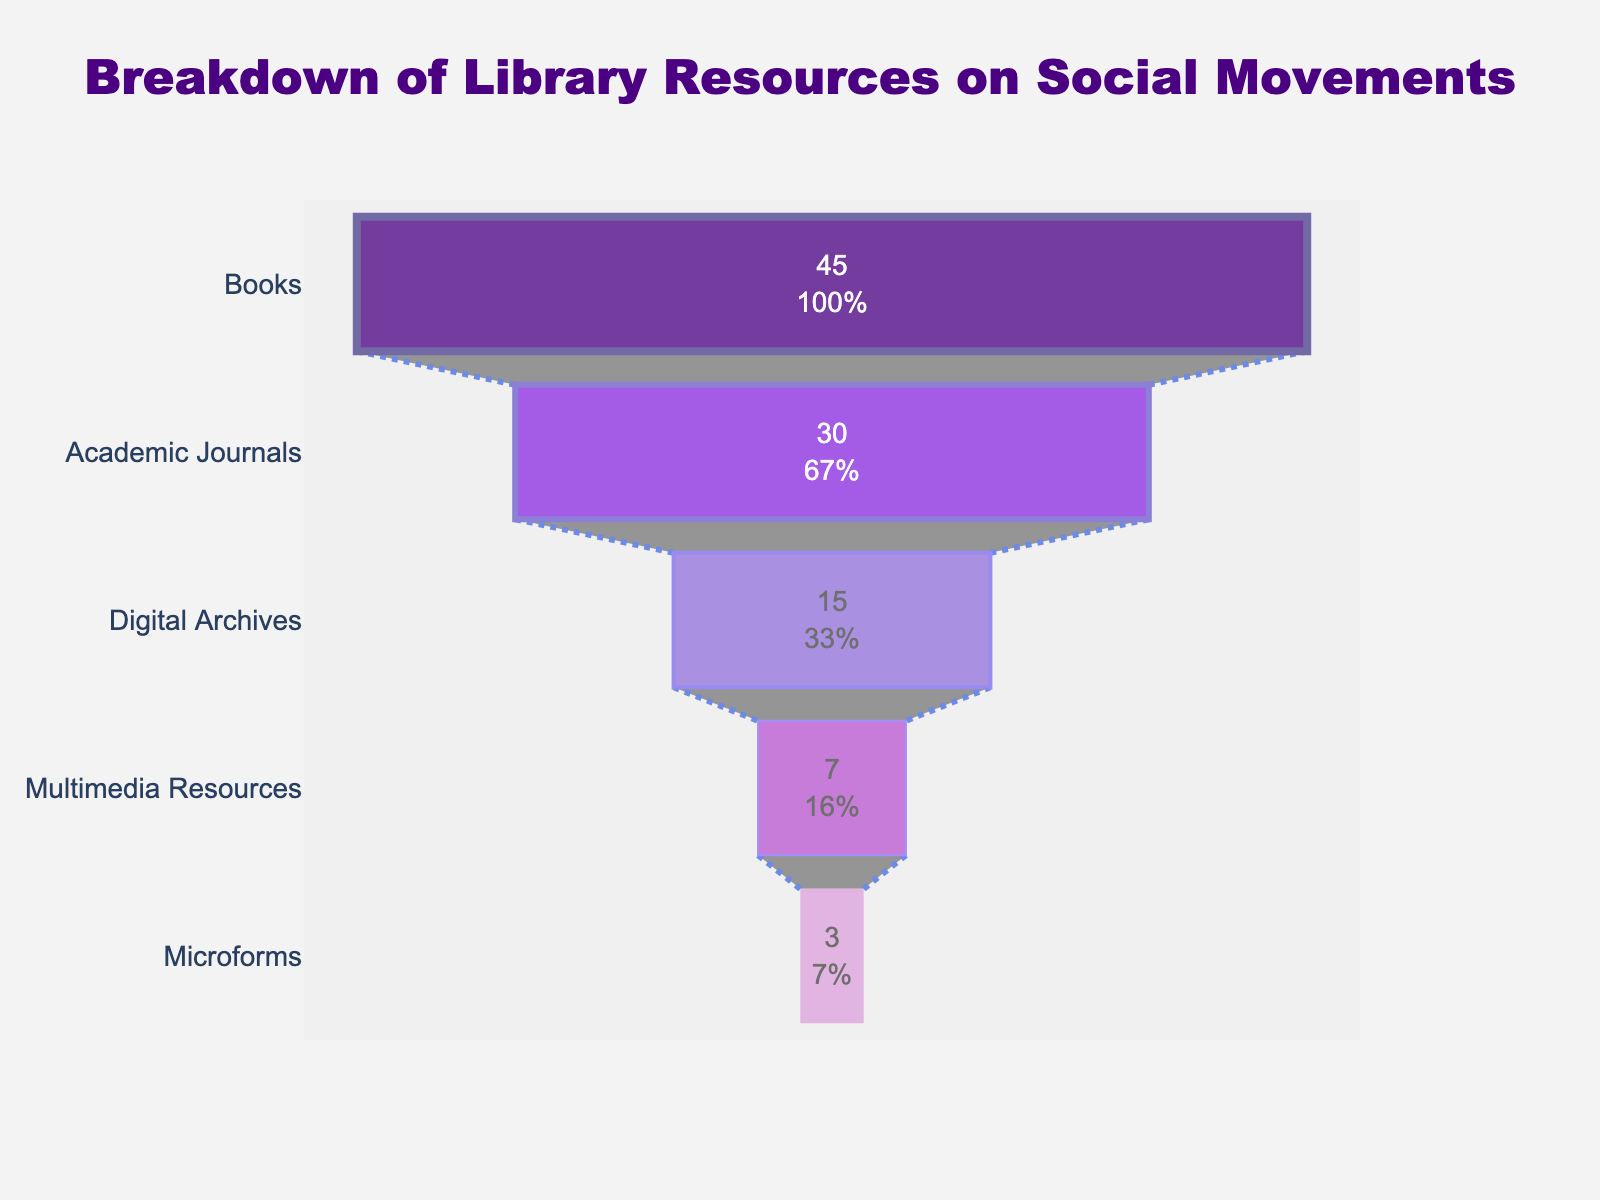What's the largest category of library resources on social movements? The title of the chart is "Breakdown of Library Resources on Social Movements", and the largest segment highlighted in the chart represents the highest percentage. The books segment is at the top, which means it's the largest category.
Answer: Books What percentage of resources are digital archives? Look for the segment labeled "Digital Archives" and directly read the percentage associated with it.
Answer: 15% How many types of library resources on social movements are represented in the chart? Count the unique segments of the chart representing different mediums. The segments are Books, Academic Journals, Digital Archives, Multimedia Resources, and Microforms.
Answer: 5 Which category represents the second highest percentage of resources? The second segment from the top of the funnel chart represents the second highest category, which is "Academic Journals" at 30%.
Answer: Academic Journals What's the combined percentage of multimedia resources and microforms? Add the percentages of the multimedia resources (7%) and microforms (3%) segments. The combined percentage is \(7\% + 3\% = 10\%\).
Answer: 10% What is the difference in percentage between books and academic journals? Subtract the percentage of academic journals (30%) from the percentage of books (45%). The difference is \(45\% - 30\% = 15\%\).
Answer: 15% Which types of library resources account for less than 10% individually? Identify the segments with percentages less than 10%. These are Multimedia Resources (7%) and Microforms (3%).
Answer: Multimedia Resources and Microforms How do digital archives compare to academic journals in terms of percentage? Compare the percentages of digital archives (15%) and academic journals (30%). Academic journals are greater than digital archives.
Answer: Academic Journals are greater How is the total percentage of library resources distributed across books, academic journals, and digital archives? Sum the percentages of books (45%), academic journals (30%), and digital archives (15%). The total proportion is \(45\% + 30\% + 15\% = 90\%\).
Answer: 90% What visual elements are used to distinguish different categories in the funnel chart? The chart uses different colors for each category and varying line widths for the boundaries of each segment. Specific colors like indigo, purple, and violet shades along with different line widths help distinguish the categories.
Answer: Different colors and line widths 